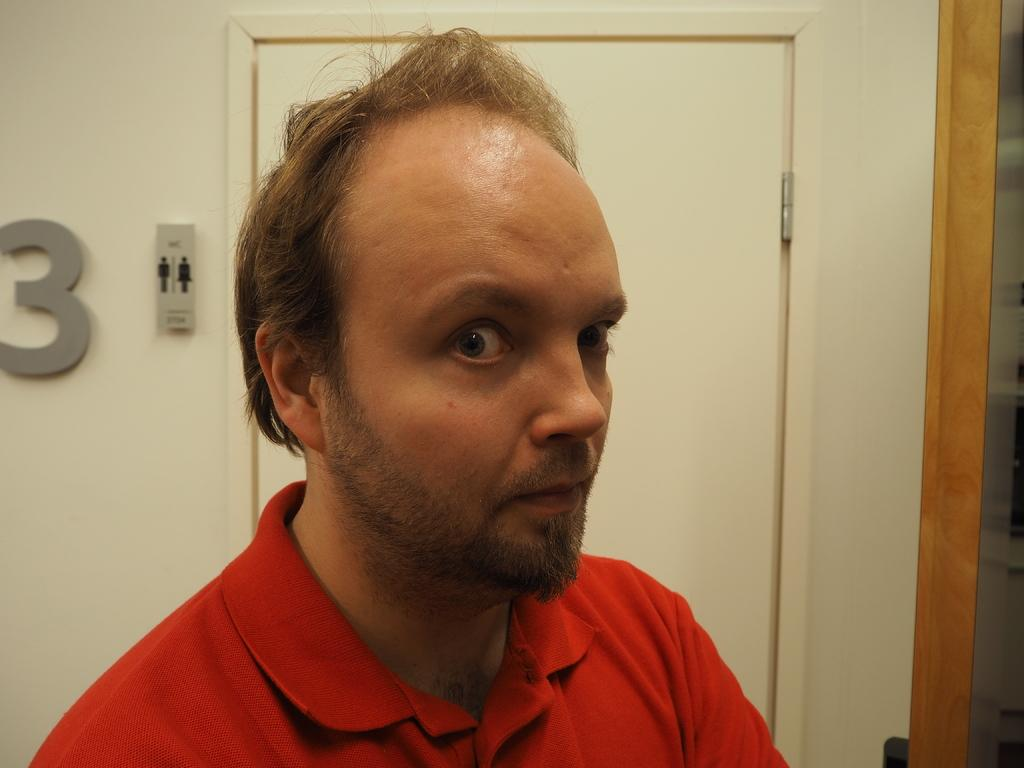What is the main subject of the image? There is a person standing in the image. What is the person wearing? The person is wearing a red t-shirt. What can be seen in the background of the image? There is a white wall in the background of the image. How many units of dirt can be seen on the person's shoes in the image? There is no dirt visible on the person's shoes in the image. What language is the person speaking in the image? The image does not provide any information about the person speaking or the language being spoken. 